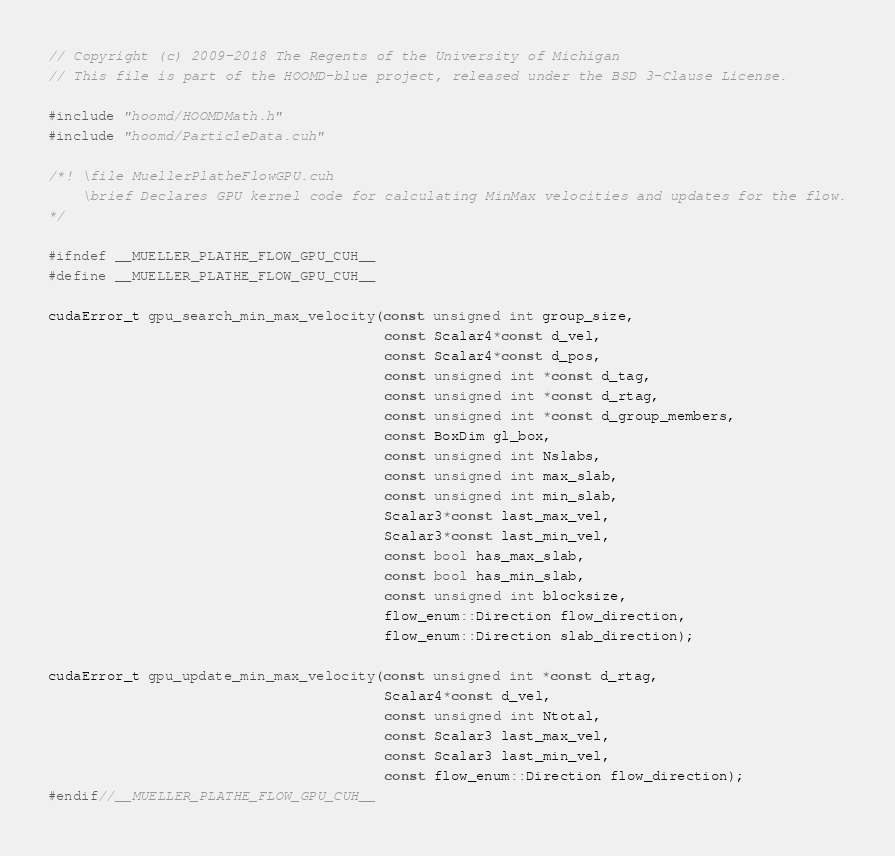Convert code to text. <code><loc_0><loc_0><loc_500><loc_500><_Cuda_>// Copyright (c) 2009-2018 The Regents of the University of Michigan
// This file is part of the HOOMD-blue project, released under the BSD 3-Clause License.

#include "hoomd/HOOMDMath.h"
#include "hoomd/ParticleData.cuh"

/*! \file MuellerPlatheFlowGPU.cuh
    \brief Declares GPU kernel code for calculating MinMax velocities and updates for the flow.
*/

#ifndef __MUELLER_PLATHE_FLOW_GPU_CUH__
#define __MUELLER_PLATHE_FLOW_GPU_CUH__

cudaError_t gpu_search_min_max_velocity(const unsigned int group_size,
                                        const Scalar4*const d_vel,
                                        const Scalar4*const d_pos,
                                        const unsigned int *const d_tag,
                                        const unsigned int *const d_rtag,
                                        const unsigned int *const d_group_members,
                                        const BoxDim gl_box,
                                        const unsigned int Nslabs,
                                        const unsigned int max_slab,
                                        const unsigned int min_slab,
                                        Scalar3*const last_max_vel,
                                        Scalar3*const last_min_vel,
                                        const bool has_max_slab,
                                        const bool has_min_slab,
                                        const unsigned int blocksize,
                                        flow_enum::Direction flow_direction,
                                        flow_enum::Direction slab_direction);

cudaError_t gpu_update_min_max_velocity(const unsigned int *const d_rtag,
                                        Scalar4*const d_vel,
                                        const unsigned int Ntotal,
                                        const Scalar3 last_max_vel,
                                        const Scalar3 last_min_vel,
                                        const flow_enum::Direction flow_direction);
#endif//__MUELLER_PLATHE_FLOW_GPU_CUH__
</code> 